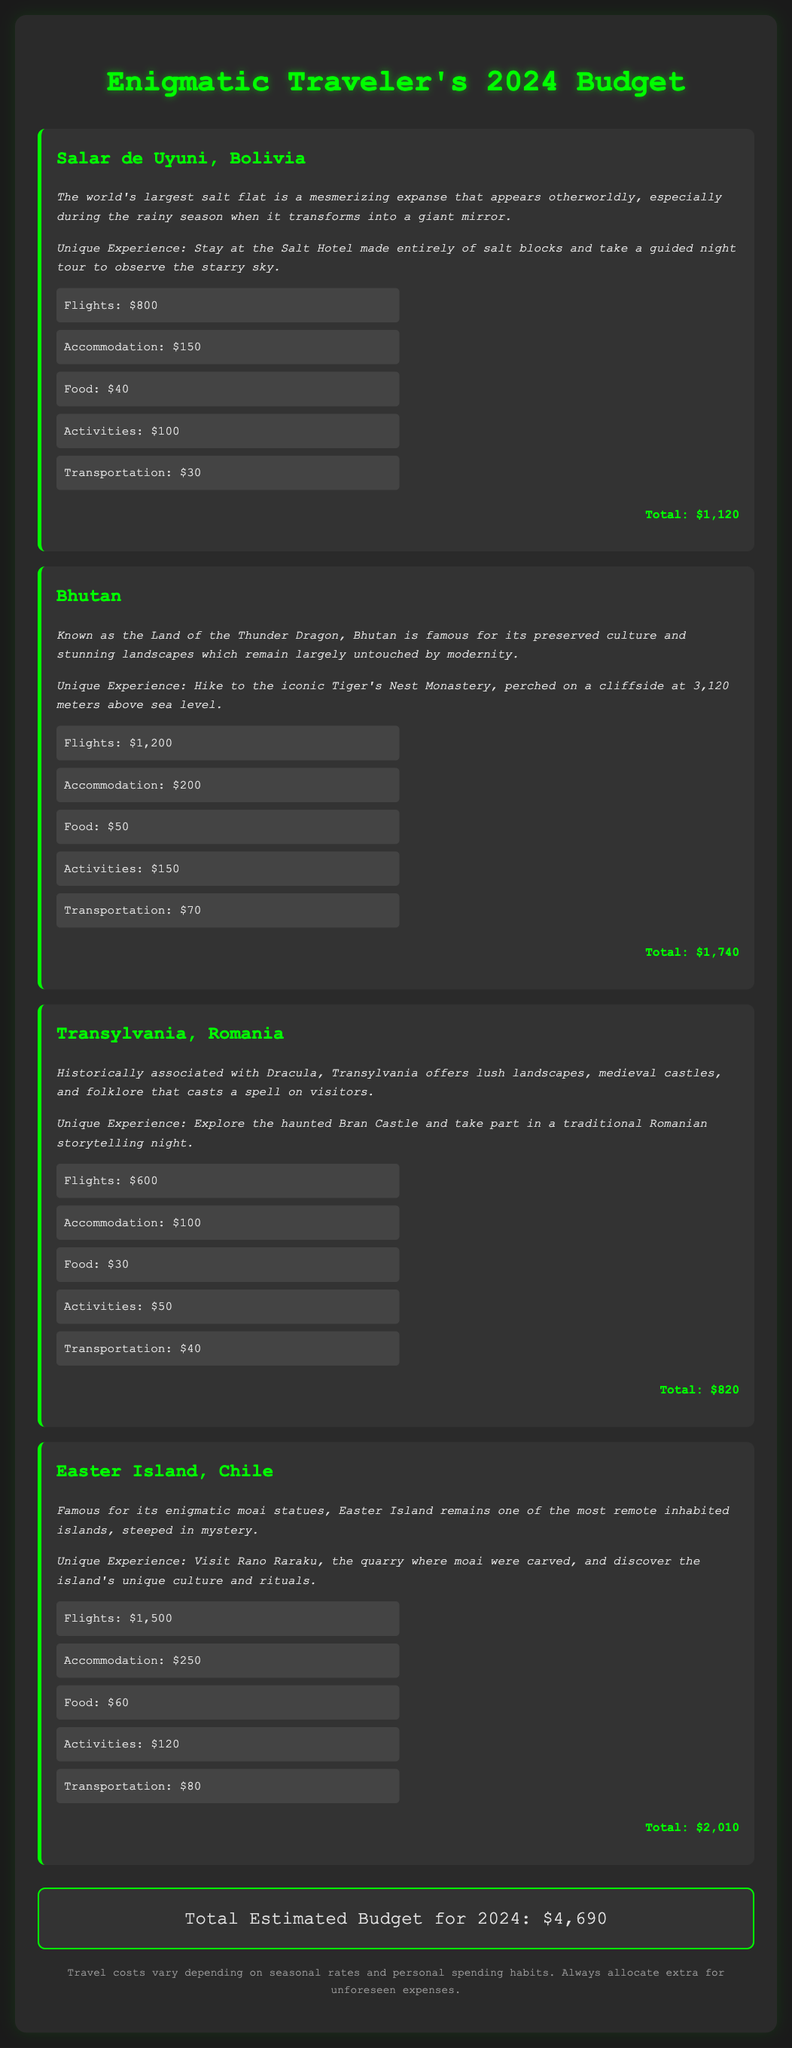What is the total estimated budget for 2024? The total estimated budget is presented at the end of the document, summing the costs across all destinations.
Answer: $4,690 How much is the accommodation cost for Bhutan? The specific accommodation cost for Bhutan is listed under its individual destination section.
Answer: $200 What unique experience is offered in Transylvania? The document describes a unique experience for Transylvania that involves visiting a specific location and participating in an activity.
Answer: Explore the haunted Bran Castle and take part in a traditional Romanian storytelling night Which destination has the highest flight cost? The flight costs for each destination must be compared to determine which one is the highest.
Answer: Easter Island, $1,500 What is the food cost for Salar de Uyuni? The food cost for Salar de Uyuni is mentioned within its individual costs section.
Answer: $40 What is the total cost for activities in Bhutan? The activities cost listed for Bhutan needs to be extracted from its costs section.
Answer: $150 Which destination is known as the Land of the Thunder Dragon? This phrase is directly referenced in the description of one of the destinations in the document.
Answer: Bhutan What is a notable feature of Salar de Uyuni? The document highlights a specific characteristic of Salar de Uyuni in its description.
Answer: It transforms into a giant mirror 